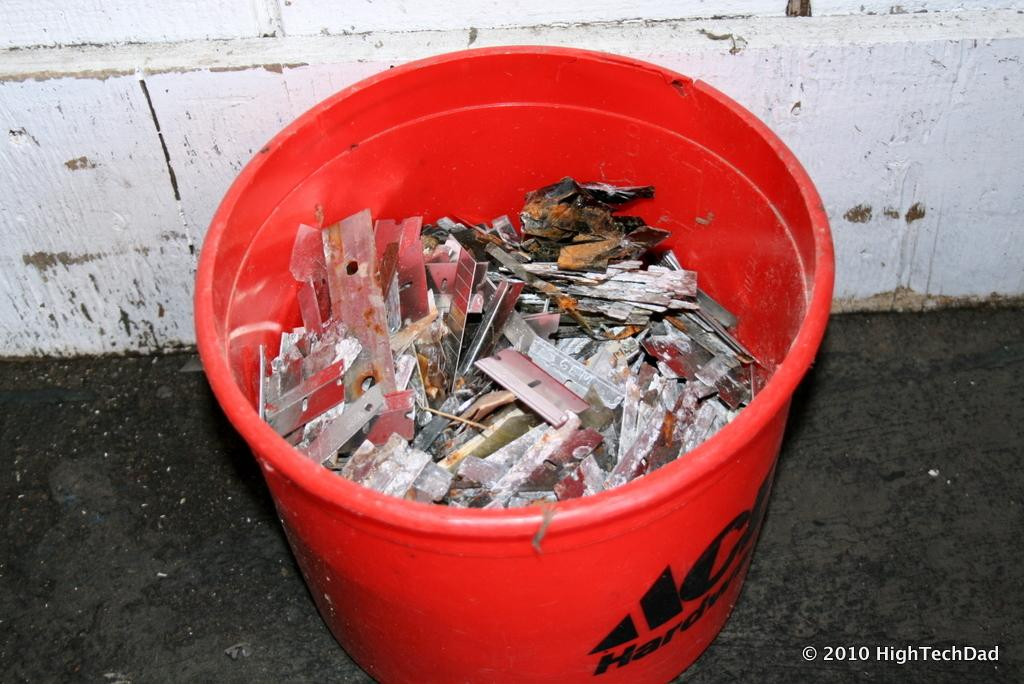Provide a one-sentence caption for the provided image. A red Ace Hardware bucket is full of used razor blades and debris. 